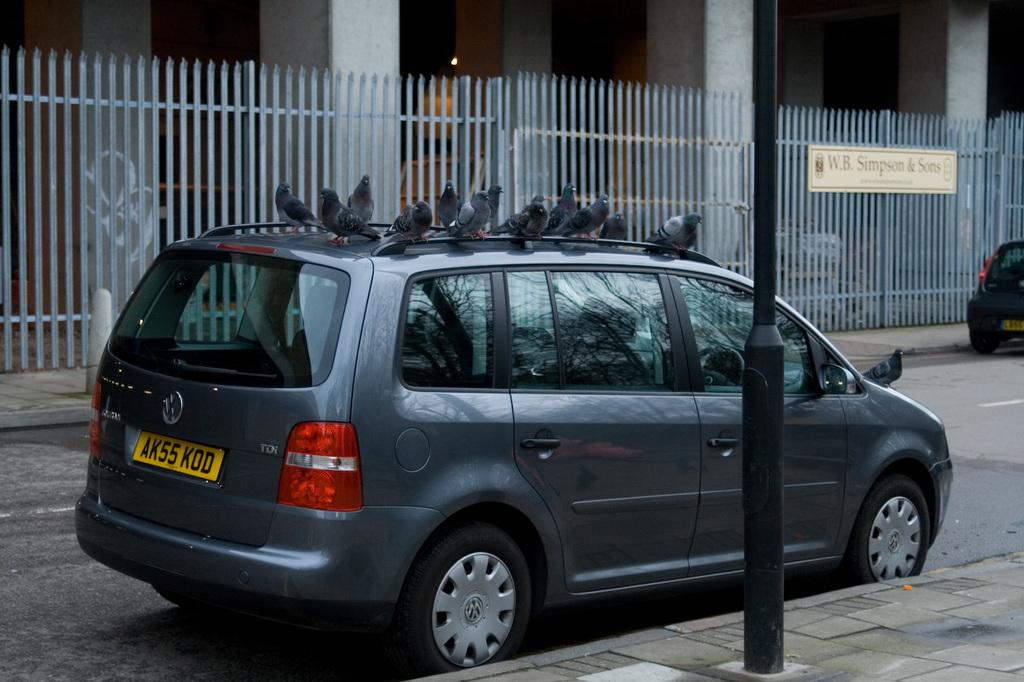<image>
Offer a succinct explanation of the picture presented. A van with many pigeons sitting on top of it is parked outside of W.B. Simpson & Sons. 